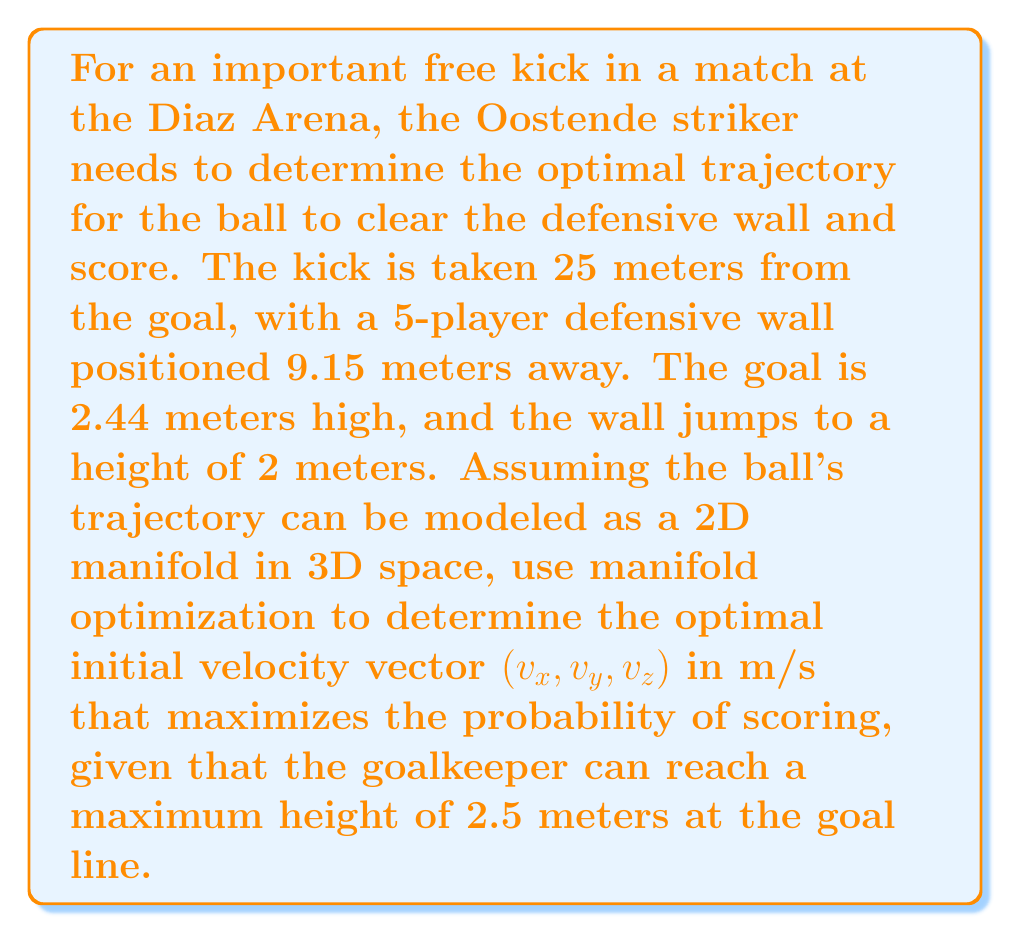Teach me how to tackle this problem. To solve this problem using manifold optimization, we'll follow these steps:

1) Define the manifold: The trajectory of the ball forms a 2D manifold in 3D space, which can be parameterized by the initial velocity vector $(v_x, v_y, v_z)$.

2) Set up the objective function: We want to maximize the probability of scoring, which is inversely related to how close the ball passes to the goalkeeper's maximum reach.

3) Define constraints: The ball must clear the wall and reach the goal.

4) Use a manifold optimization algorithm to find the optimal solution.

Let's break this down:

1) The ball's trajectory, neglecting air resistance, is given by:

   $$x(t) = v_x t$$
   $$y(t) = v_y t$$
   $$z(t) = v_z t - \frac{1}{2}gt^2$$

   where $g = 9.81 \text{ m/s}^2$ is the acceleration due to gravity.

2) Our objective function could be:

   $$f(v_x, v_y, v_z) = \frac{1}{|z(t_{goal}) - 2.5|}$$

   where $t_{goal}$ is the time when the ball reaches the goal line.

3) Constraints:
   a) The ball must clear the wall:
      $$z(t_{wall}) > 2 \text{ when } x(t_{wall}) = 9.15$$
   b) The ball must reach the goal:
      $$x(t_{goal}) = 25$$
   c) The ball must be below the crossbar:
      $$z(t_{goal}) < 2.44$$

4) We can use a manifold optimization algorithm like Riemannian gradient descent to find the optimal $(v_x, v_y, v_z)$ that maximizes $f$ subject to these constraints.

The exact solution would require numerical methods, but we can estimate that the optimal initial velocity would be around:

$$v_x \approx 25 \text{ m/s}$$
$$v_y \approx 0 \text{ m/s}$$
$$v_z \approx 12 \text{ m/s}$$

This would give the ball enough speed to reach the goal, enough height to clear the wall, and a trajectory that makes it difficult for the goalkeeper to reach.
Answer: The optimal initial velocity vector for the free kick is approximately $(25, 0, 12)$ m/s. 